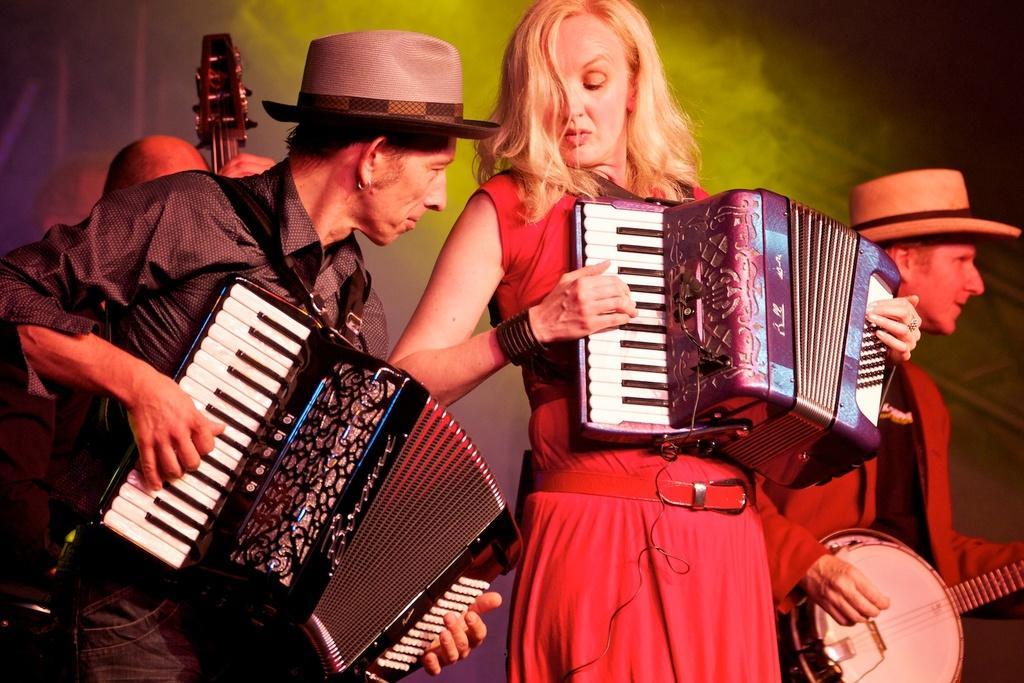Describe this image in one or two sentences. On the left side, there is a person wearing a cap and playing a musical instrument. Beside him, there is a woman in a red color dress, standing and playing a musical instrument. On the right side, there is a person wearing a cap and playing a guitar. In the background, there is another person and there is smoke. And the background is dark in color. 